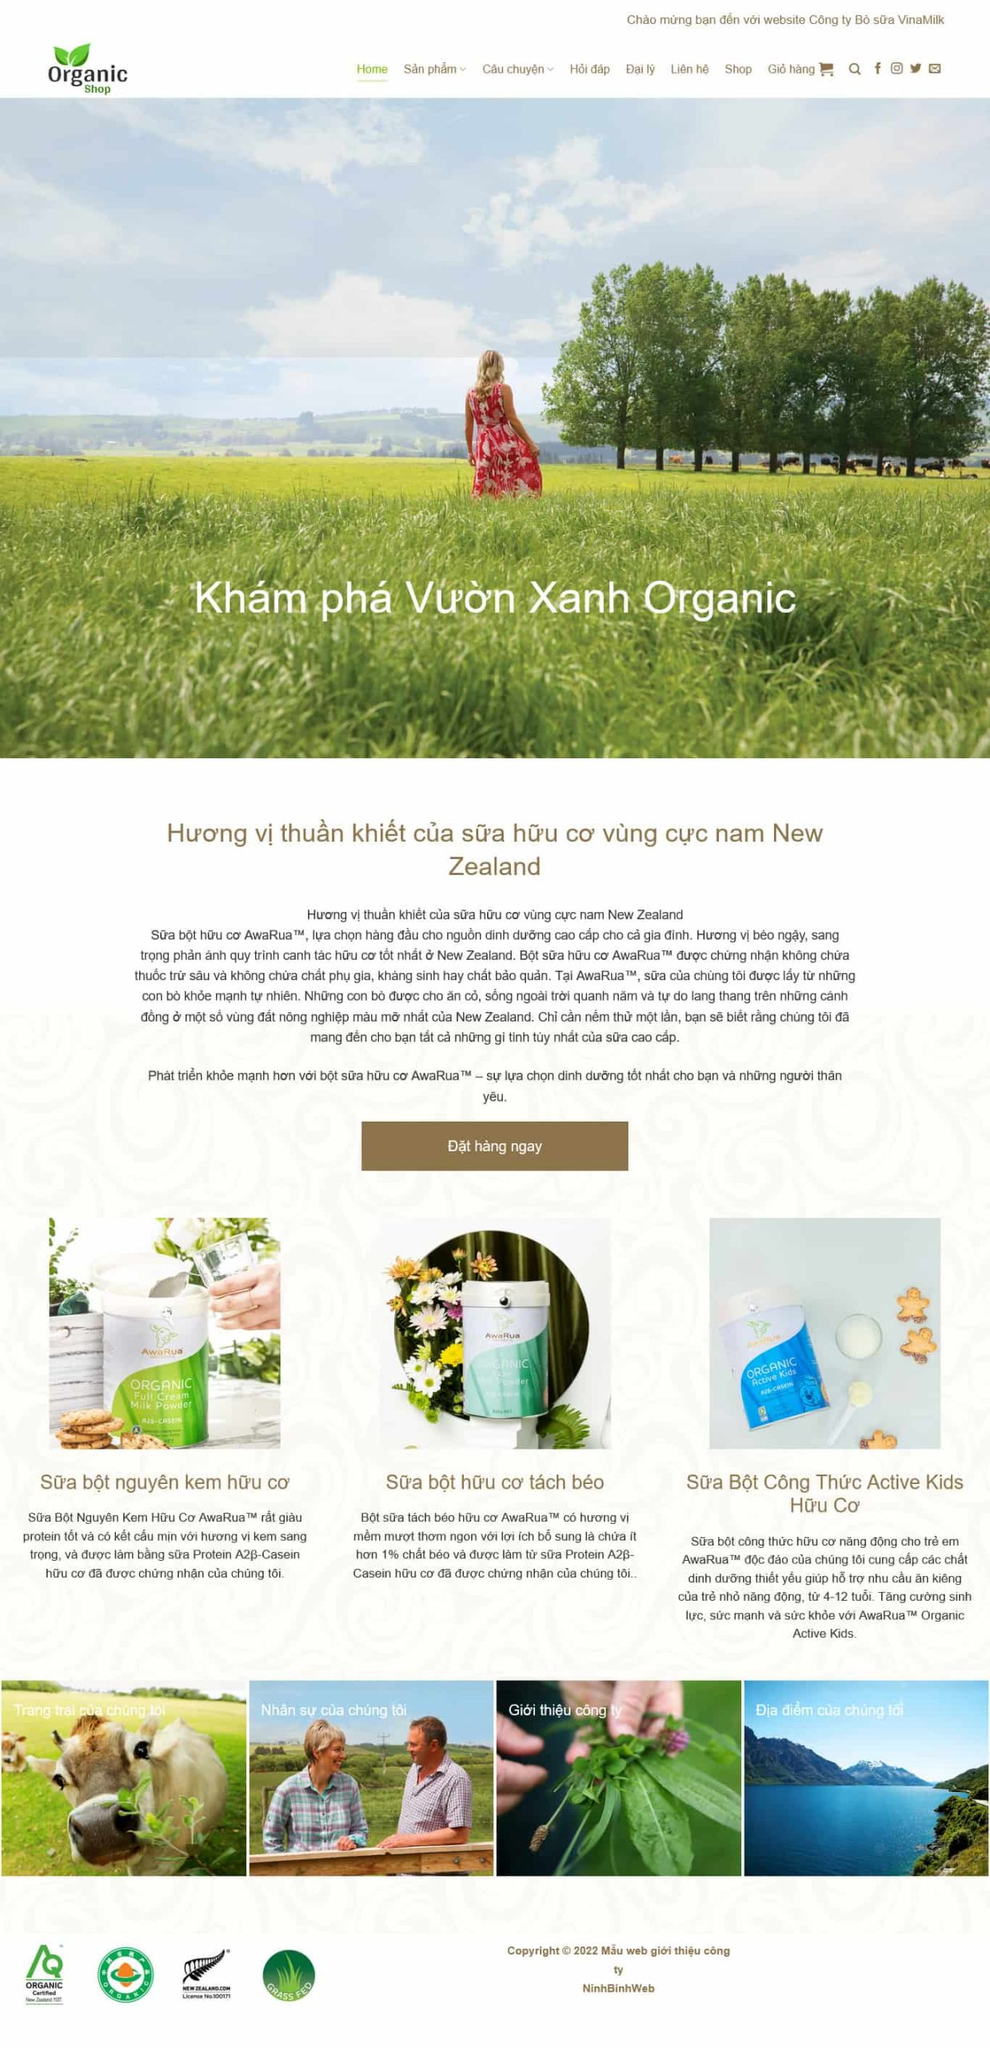Liệt kê 5 ngành nghề, lĩnh vực phù hợp với website này, phân cách các màu sắc bằng dấu phẩy. Chỉ trả về kết quả, phân cách bằng dấy phẩy
 Nông nghiệp, Thực phẩm hữu cơ, Sữa và sản phẩm từ sữa, Chăm sóc sức khỏe, Thương mại điện tử 